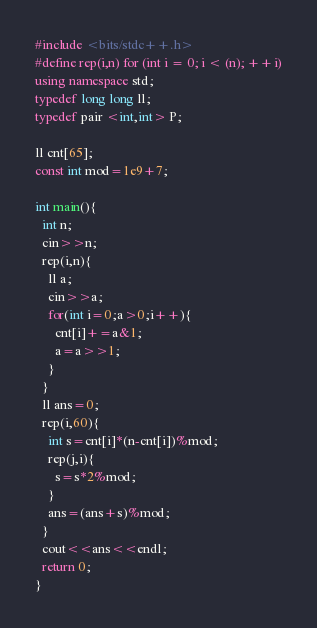Convert code to text. <code><loc_0><loc_0><loc_500><loc_500><_C++_>#include <bits/stdc++.h>
#define rep(i,n) for (int i = 0; i < (n); ++i)
using namespace std;
typedef long long ll;
typedef pair <int,int> P;

ll cnt[65];
const int mod=1e9+7;

int main(){
  int n;
  cin>>n;
  rep(i,n){
    ll a;
    cin>>a;
    for(int i=0;a>0;i++){
      cnt[i]+=a&1;
      a=a>>1;
    }
  }
  ll ans=0;
  rep(i,60){
    int s=cnt[i]*(n-cnt[i])%mod;
    rep(j,i){
      s=s*2%mod;
    }
    ans=(ans+s)%mod;
  }
  cout<<ans<<endl;
  return 0;
}

</code> 